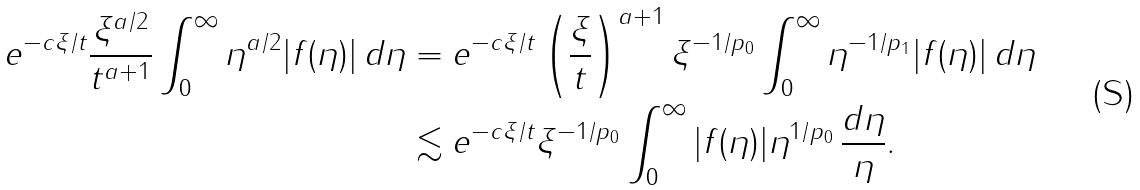Convert formula to latex. <formula><loc_0><loc_0><loc_500><loc_500>e ^ { - c \xi \slash t } \frac { \xi ^ { a / 2 } } { t ^ { a + 1 } } \int _ { 0 } ^ { \infty } \eta ^ { a / 2 } | f ( \eta ) | \, d \eta & = e ^ { - c \xi \slash t } \left ( \frac { \xi } { t } \right ) ^ { a + 1 } \xi ^ { - 1 \slash p _ { 0 } } \int _ { 0 } ^ { \infty } \eta ^ { - 1 \slash p _ { 1 } } | f ( \eta ) | \, d \eta \\ & \lesssim e ^ { - { c } \xi \slash t } \xi ^ { - 1 / p _ { 0 } } \int _ { 0 } ^ { \infty } | f ( \eta ) | \eta ^ { 1 \slash p _ { 0 } } \, \frac { d \eta } { \eta } .</formula> 